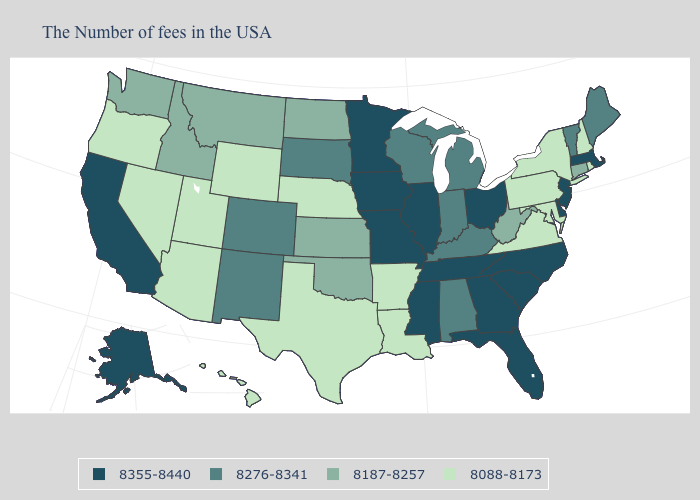What is the value of Missouri?
Answer briefly. 8355-8440. Name the states that have a value in the range 8276-8341?
Quick response, please. Maine, Vermont, Michigan, Kentucky, Indiana, Alabama, Wisconsin, South Dakota, Colorado, New Mexico. Name the states that have a value in the range 8276-8341?
Be succinct. Maine, Vermont, Michigan, Kentucky, Indiana, Alabama, Wisconsin, South Dakota, Colorado, New Mexico. Does the first symbol in the legend represent the smallest category?
Give a very brief answer. No. Name the states that have a value in the range 8187-8257?
Write a very short answer. Connecticut, West Virginia, Kansas, Oklahoma, North Dakota, Montana, Idaho, Washington. Among the states that border Massachusetts , does New Hampshire have the highest value?
Be succinct. No. Does New Mexico have the same value as Michigan?
Give a very brief answer. Yes. What is the lowest value in the MidWest?
Answer briefly. 8088-8173. What is the highest value in states that border Arizona?
Give a very brief answer. 8355-8440. Name the states that have a value in the range 8355-8440?
Be succinct. Massachusetts, New Jersey, Delaware, North Carolina, South Carolina, Ohio, Florida, Georgia, Tennessee, Illinois, Mississippi, Missouri, Minnesota, Iowa, California, Alaska. What is the value of Montana?
Give a very brief answer. 8187-8257. What is the highest value in the USA?
Give a very brief answer. 8355-8440. Among the states that border Oregon , which have the lowest value?
Write a very short answer. Nevada. What is the value of Louisiana?
Quick response, please. 8088-8173. Does Indiana have the highest value in the MidWest?
Be succinct. No. 